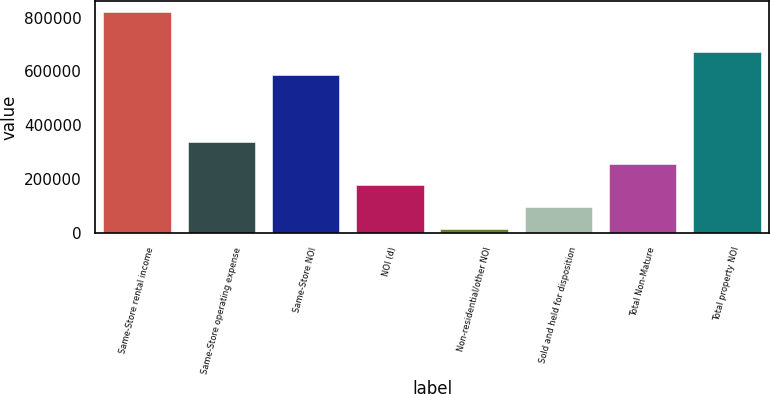<chart> <loc_0><loc_0><loc_500><loc_500><bar_chart><fcel>Same-Store rental income<fcel>Same-Store operating expense<fcel>Same-Store NOI<fcel>NOI (d)<fcel>Non-residential/other NOI<fcel>Sold and held for disposition<fcel>Total Non-Mature<fcel>Total property NOI<nl><fcel>819962<fcel>337731<fcel>585577<fcel>176988<fcel>16244<fcel>96615.8<fcel>257359<fcel>673085<nl></chart> 